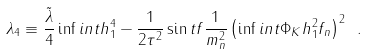<formula> <loc_0><loc_0><loc_500><loc_500>\lambda _ { 4 } \equiv \frac { \tilde { \lambda } } { 4 } \inf i n t h _ { 1 } ^ { 4 } - { \frac { 1 } { 2 \tau ^ { 2 } } \sin t f \frac { 1 } { m _ { n } ^ { 2 } } \left ( \inf i n t \Phi _ { K } h _ { 1 } ^ { 2 } f _ { n } \right ) ^ { 2 } } \ .</formula> 